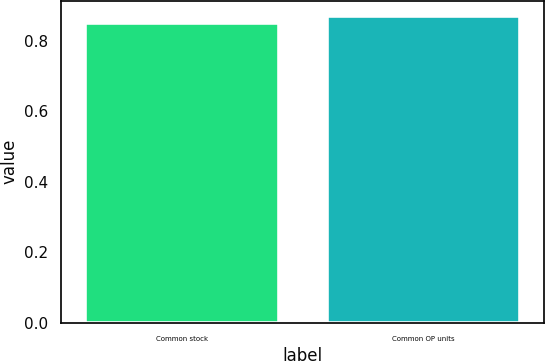<chart> <loc_0><loc_0><loc_500><loc_500><bar_chart><fcel>Common stock<fcel>Common OP units<nl><fcel>0.85<fcel>0.87<nl></chart> 